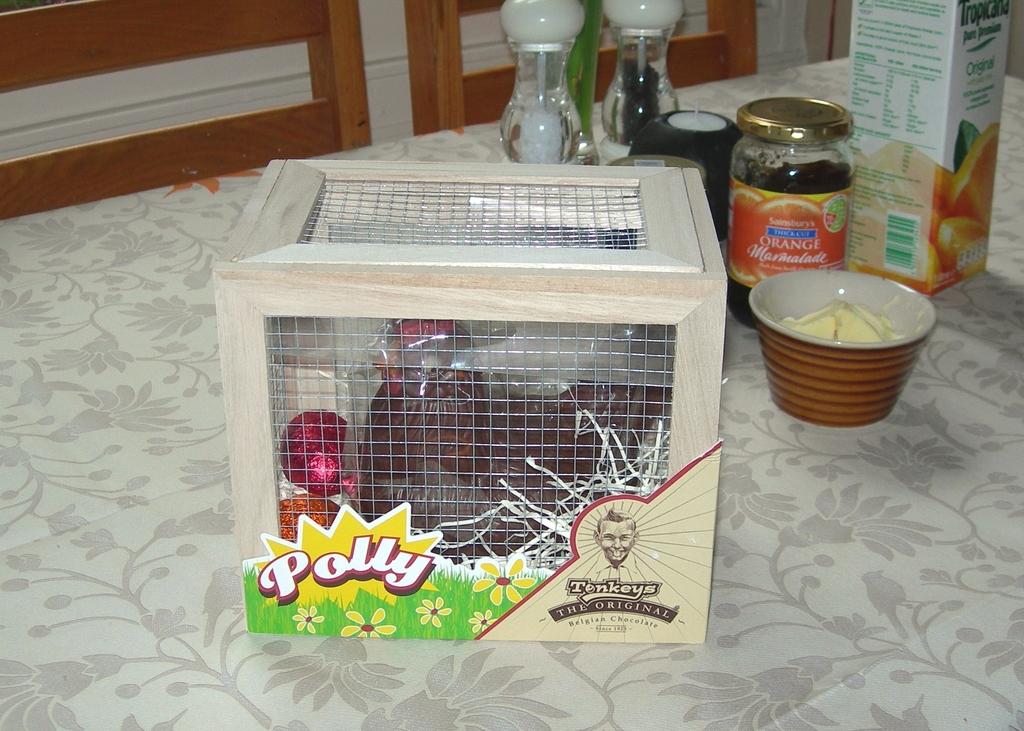What name is on the box?
Offer a terse response. Polly. 